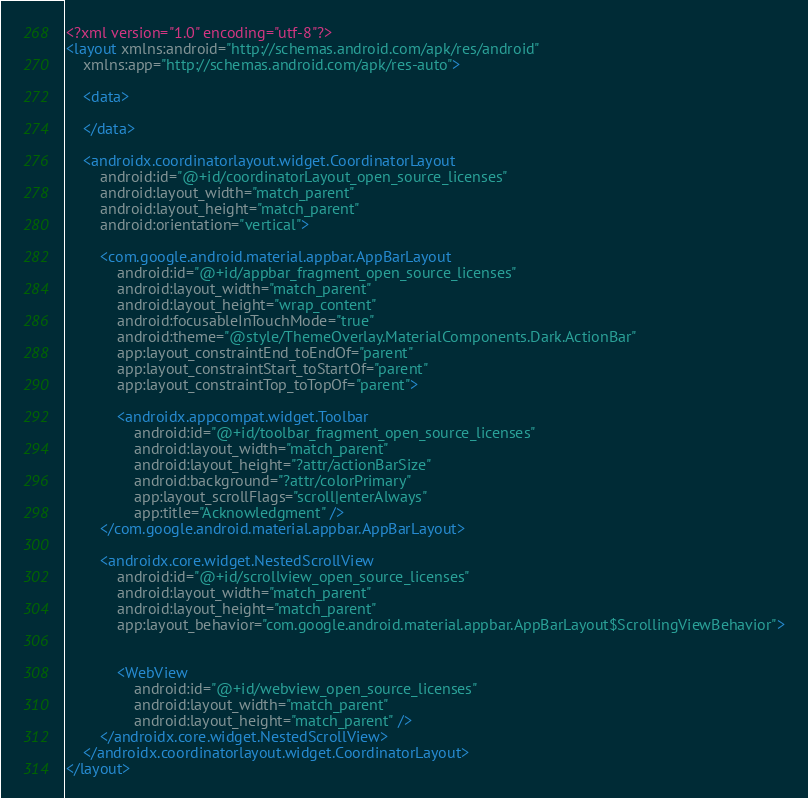Convert code to text. <code><loc_0><loc_0><loc_500><loc_500><_XML_><?xml version="1.0" encoding="utf-8"?>
<layout xmlns:android="http://schemas.android.com/apk/res/android"
    xmlns:app="http://schemas.android.com/apk/res-auto">

    <data>

    </data>

    <androidx.coordinatorlayout.widget.CoordinatorLayout
        android:id="@+id/coordinatorLayout_open_source_licenses"
        android:layout_width="match_parent"
        android:layout_height="match_parent"
        android:orientation="vertical">

        <com.google.android.material.appbar.AppBarLayout
            android:id="@+id/appbar_fragment_open_source_licenses"
            android:layout_width="match_parent"
            android:layout_height="wrap_content"
            android:focusableInTouchMode="true"
            android:theme="@style/ThemeOverlay.MaterialComponents.Dark.ActionBar"
            app:layout_constraintEnd_toEndOf="parent"
            app:layout_constraintStart_toStartOf="parent"
            app:layout_constraintTop_toTopOf="parent">

            <androidx.appcompat.widget.Toolbar
                android:id="@+id/toolbar_fragment_open_source_licenses"
                android:layout_width="match_parent"
                android:layout_height="?attr/actionBarSize"
                android:background="?attr/colorPrimary"
                app:layout_scrollFlags="scroll|enterAlways"
                app:title="Acknowledgment" />
        </com.google.android.material.appbar.AppBarLayout>

        <androidx.core.widget.NestedScrollView
            android:id="@+id/scrollview_open_source_licenses"
            android:layout_width="match_parent"
            android:layout_height="match_parent"
            app:layout_behavior="com.google.android.material.appbar.AppBarLayout$ScrollingViewBehavior">


            <WebView
                android:id="@+id/webview_open_source_licenses"
                android:layout_width="match_parent"
                android:layout_height="match_parent" />
        </androidx.core.widget.NestedScrollView>
    </androidx.coordinatorlayout.widget.CoordinatorLayout>
</layout></code> 